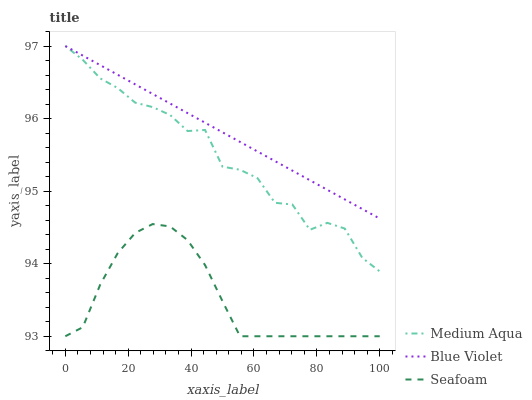Does Seafoam have the minimum area under the curve?
Answer yes or no. Yes. Does Blue Violet have the maximum area under the curve?
Answer yes or no. Yes. Does Blue Violet have the minimum area under the curve?
Answer yes or no. No. Does Seafoam have the maximum area under the curve?
Answer yes or no. No. Is Blue Violet the smoothest?
Answer yes or no. Yes. Is Medium Aqua the roughest?
Answer yes or no. Yes. Is Seafoam the smoothest?
Answer yes or no. No. Is Seafoam the roughest?
Answer yes or no. No. Does Blue Violet have the lowest value?
Answer yes or no. No. Does Seafoam have the highest value?
Answer yes or no. No. Is Seafoam less than Blue Violet?
Answer yes or no. Yes. Is Blue Violet greater than Seafoam?
Answer yes or no. Yes. Does Seafoam intersect Blue Violet?
Answer yes or no. No. 